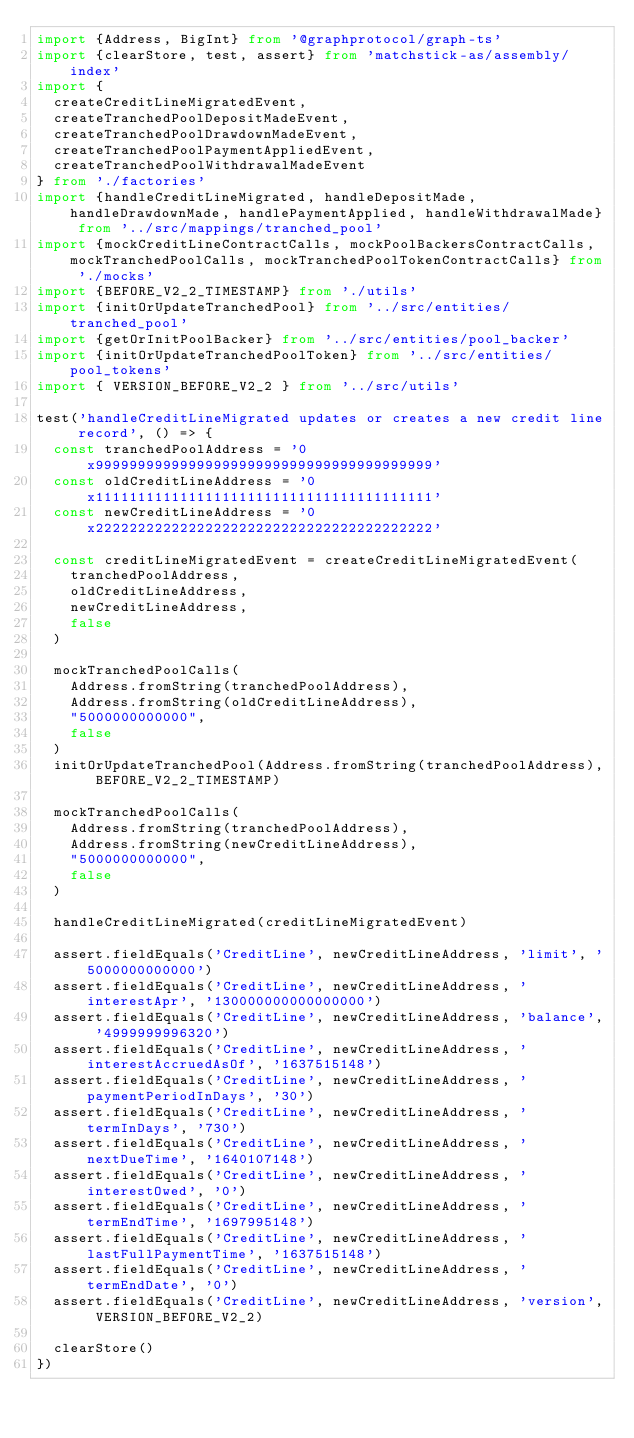<code> <loc_0><loc_0><loc_500><loc_500><_TypeScript_>import {Address, BigInt} from '@graphprotocol/graph-ts'
import {clearStore, test, assert} from 'matchstick-as/assembly/index'
import {
  createCreditLineMigratedEvent,
  createTranchedPoolDepositMadeEvent,
  createTranchedPoolDrawdownMadeEvent,
  createTranchedPoolPaymentAppliedEvent,
  createTranchedPoolWithdrawalMadeEvent
} from './factories'
import {handleCreditLineMigrated, handleDepositMade, handleDrawdownMade, handlePaymentApplied, handleWithdrawalMade} from '../src/mappings/tranched_pool'
import {mockCreditLineContractCalls, mockPoolBackersContractCalls, mockTranchedPoolCalls, mockTranchedPoolTokenContractCalls} from './mocks'
import {BEFORE_V2_2_TIMESTAMP} from './utils'
import {initOrUpdateTranchedPool} from '../src/entities/tranched_pool'
import {getOrInitPoolBacker} from '../src/entities/pool_backer'
import {initOrUpdateTranchedPoolToken} from '../src/entities/pool_tokens'
import { VERSION_BEFORE_V2_2 } from '../src/utils'

test('handleCreditLineMigrated updates or creates a new credit line record', () => {
  const tranchedPoolAddress = '0x9999999999999999999999999999999999999999'
  const oldCreditLineAddress = '0x1111111111111111111111111111111111111111'
  const newCreditLineAddress = '0x2222222222222222222222222222222222222222'

  const creditLineMigratedEvent = createCreditLineMigratedEvent(
    tranchedPoolAddress,
    oldCreditLineAddress,
    newCreditLineAddress,
    false
  )

  mockTranchedPoolCalls(
    Address.fromString(tranchedPoolAddress),
    Address.fromString(oldCreditLineAddress),
    "5000000000000",
    false
  )
  initOrUpdateTranchedPool(Address.fromString(tranchedPoolAddress), BEFORE_V2_2_TIMESTAMP)

  mockTranchedPoolCalls(
    Address.fromString(tranchedPoolAddress),
    Address.fromString(newCreditLineAddress),
    "5000000000000",
    false
  )

  handleCreditLineMigrated(creditLineMigratedEvent)

  assert.fieldEquals('CreditLine', newCreditLineAddress, 'limit', '5000000000000')
  assert.fieldEquals('CreditLine', newCreditLineAddress, 'interestApr', '130000000000000000')
  assert.fieldEquals('CreditLine', newCreditLineAddress, 'balance', '4999999996320')
  assert.fieldEquals('CreditLine', newCreditLineAddress, 'interestAccruedAsOf', '1637515148')
  assert.fieldEquals('CreditLine', newCreditLineAddress, 'paymentPeriodInDays', '30')
  assert.fieldEquals('CreditLine', newCreditLineAddress, 'termInDays', '730')
  assert.fieldEquals('CreditLine', newCreditLineAddress, 'nextDueTime', '1640107148')
  assert.fieldEquals('CreditLine', newCreditLineAddress, 'interestOwed', '0')
  assert.fieldEquals('CreditLine', newCreditLineAddress, 'termEndTime', '1697995148')
  assert.fieldEquals('CreditLine', newCreditLineAddress, 'lastFullPaymentTime', '1637515148')
  assert.fieldEquals('CreditLine', newCreditLineAddress, 'termEndDate', '0')
  assert.fieldEquals('CreditLine', newCreditLineAddress, 'version', VERSION_BEFORE_V2_2)

  clearStore()
})
</code> 